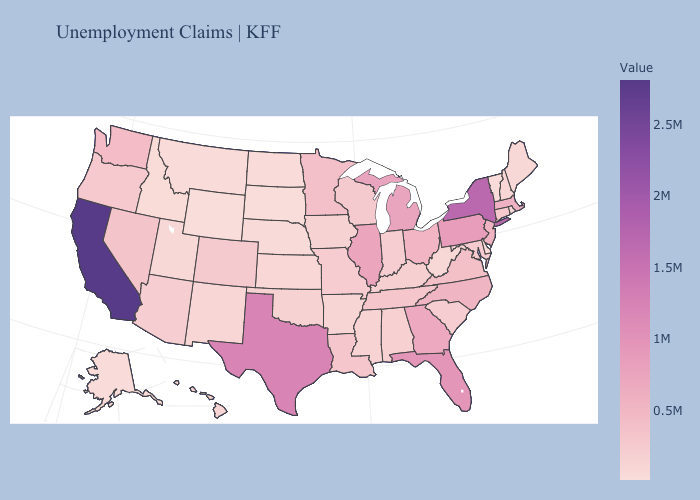Does West Virginia have a lower value than Washington?
Be succinct. Yes. Among the states that border Texas , does Louisiana have the lowest value?
Give a very brief answer. No. Which states have the lowest value in the USA?
Answer briefly. Wyoming. Among the states that border Colorado , which have the lowest value?
Short answer required. Wyoming. Does South Dakota have the lowest value in the MidWest?
Keep it brief. Yes. Which states have the lowest value in the USA?
Be succinct. Wyoming. Does California have the lowest value in the West?
Short answer required. No. Does the map have missing data?
Concise answer only. No. 